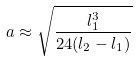Convert formula to latex. <formula><loc_0><loc_0><loc_500><loc_500>a \approx \sqrt { \frac { l _ { 1 } ^ { 3 } } { 2 4 ( l _ { 2 } - l _ { 1 } ) } }</formula> 